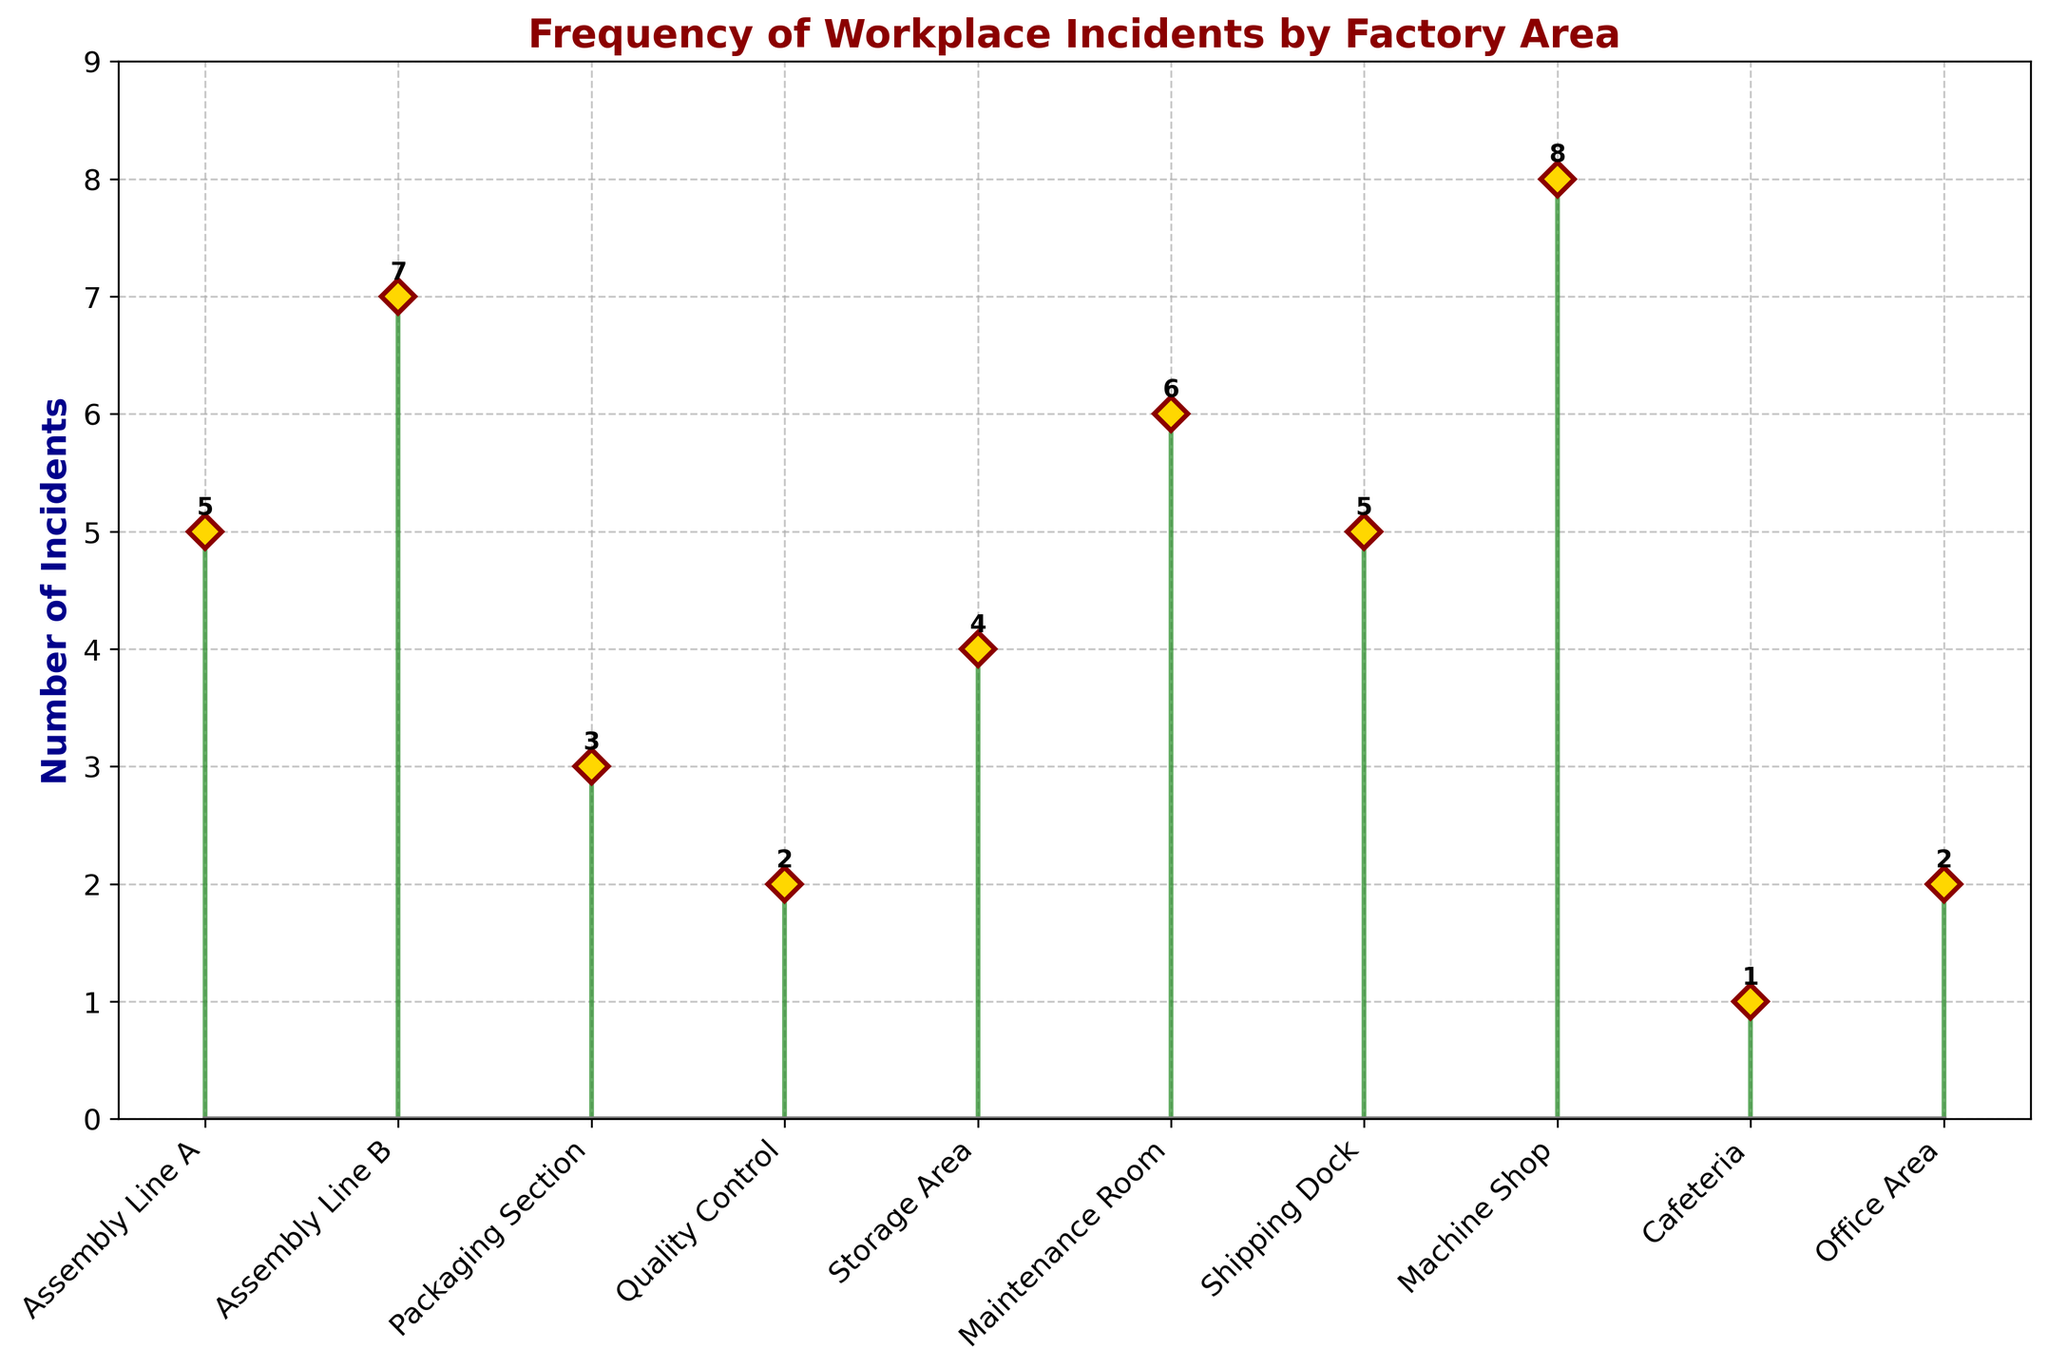What's the title of the plot? The title of the plot is displayed at the top of the figure in bold and colored dark red.
Answer: Frequency of Workplace Incidents by Factory Area How many incidents occurred in the Machine Shop? Locate the Machine Shop on the x-axis and observe the corresponding stem value.
Answer: 8 Which area had the fewest incidents? Identify the area with the shortest stem value on the plot.
Answer: Cafeteria What is the sum of incidents for Assembly Line A and Assembly Line B? Find the values for Assembly Line A and Assembly Line B on the plot and add them together (5 and 7).
Answer: 12 How does the number of incidents in the Maintenance Room compare to the Storage Area? Compare the stem values for the Maintenance Room and the Storage Area.
Answer: Maintenance Room has 2 more incidents than Storage Area What's the total number of incidents reported across all areas? Add the values of all the stems on the plot (5+7+3+2+4+6+5+8+1+2).
Answer: 43 Which area has exactly 4 incidents? Identify the area with a stem value of 4.
Answer: Storage Area Are there more incidents in the Shipping Dock or the Packaging Section? Compare the stem values for the Shipping Dock and the Packaging Section.
Answer: Shipping Dock How many areas have fewer than 3 incidents? Count the number of areas with stem values less than 3.
Answer: 2 What is the difference in incidents between the area with the most and the least incidents? Subtract the least value (1 from Cafeteria) from the most value (8 from Machine Shop).
Answer: 7 